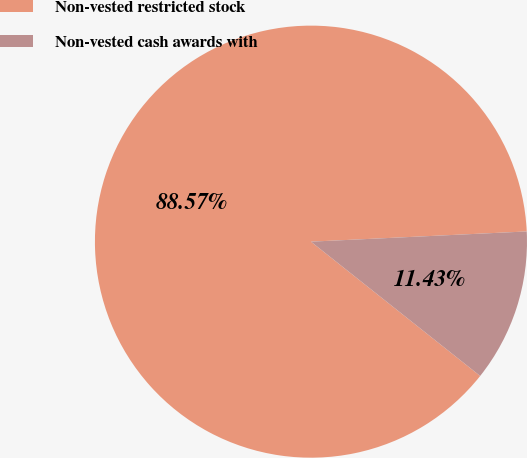Convert chart. <chart><loc_0><loc_0><loc_500><loc_500><pie_chart><fcel>Non-vested restricted stock<fcel>Non-vested cash awards with<nl><fcel>88.57%<fcel>11.43%<nl></chart> 